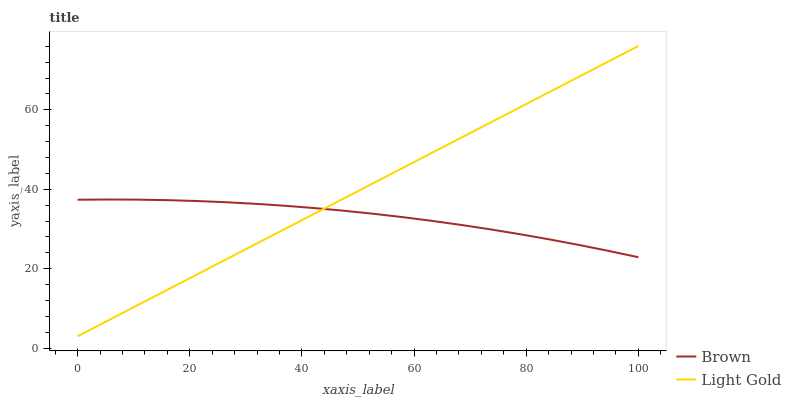Does Brown have the minimum area under the curve?
Answer yes or no. Yes. Does Light Gold have the maximum area under the curve?
Answer yes or no. Yes. Does Light Gold have the minimum area under the curve?
Answer yes or no. No. Is Light Gold the smoothest?
Answer yes or no. Yes. Is Brown the roughest?
Answer yes or no. Yes. Is Light Gold the roughest?
Answer yes or no. No. Does Light Gold have the lowest value?
Answer yes or no. Yes. Does Light Gold have the highest value?
Answer yes or no. Yes. Does Light Gold intersect Brown?
Answer yes or no. Yes. Is Light Gold less than Brown?
Answer yes or no. No. Is Light Gold greater than Brown?
Answer yes or no. No. 